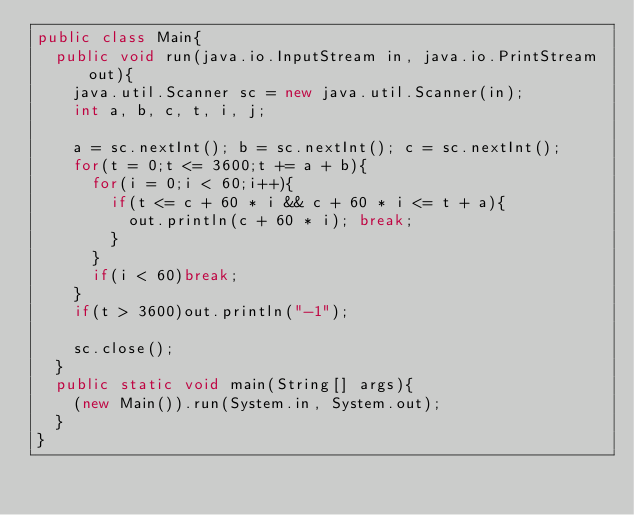Convert code to text. <code><loc_0><loc_0><loc_500><loc_500><_Java_>public class Main{
  public void run(java.io.InputStream in, java.io.PrintStream out){
    java.util.Scanner sc = new java.util.Scanner(in);
    int a, b, c, t, i, j;

    a = sc.nextInt(); b = sc.nextInt(); c = sc.nextInt();
    for(t = 0;t <= 3600;t += a + b){
      for(i = 0;i < 60;i++){
        if(t <= c + 60 * i && c + 60 * i <= t + a){
          out.println(c + 60 * i); break;
        }
      }
      if(i < 60)break;
    }
    if(t > 3600)out.println("-1");

    sc.close();
  }
  public static void main(String[] args){
    (new Main()).run(System.in, System.out);
  }
}</code> 